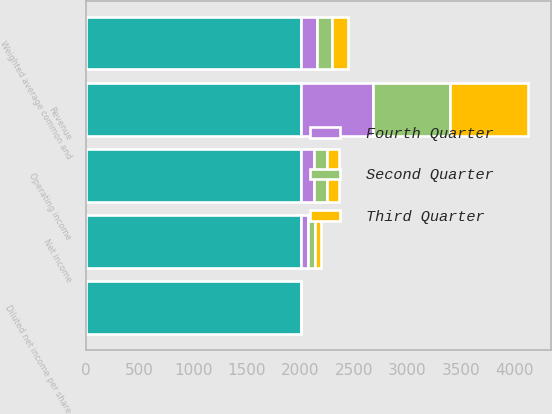Convert chart. <chart><loc_0><loc_0><loc_500><loc_500><stacked_bar_chart><ecel><fcel>Revenue<fcel>Operating income<fcel>Net income<fcel>Diluted net income per share<fcel>Weighted average common and<nl><fcel>nan<fcel>2005<fcel>2005<fcel>2005<fcel>2005<fcel>2005<nl><fcel>Fourth Quarter<fcel>677.2<fcel>119.5<fcel>65.5<fcel>0.43<fcel>151<nl><fcel>Second Quarter<fcel>718.6<fcel>122.9<fcel>64.4<fcel>0.44<fcel>145.4<nl><fcel>Third Quarter<fcel>730<fcel>119.4<fcel>63.8<fcel>0.45<fcel>142.6<nl></chart> 